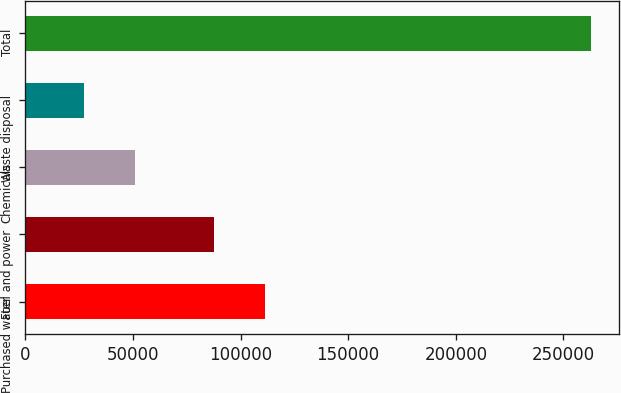Convert chart. <chart><loc_0><loc_0><loc_500><loc_500><bar_chart><fcel>Purchased water<fcel>Fuel and power<fcel>Chemicals<fcel>Waste disposal<fcel>Total<nl><fcel>111403<fcel>87879<fcel>50846.1<fcel>27322<fcel>262563<nl></chart> 